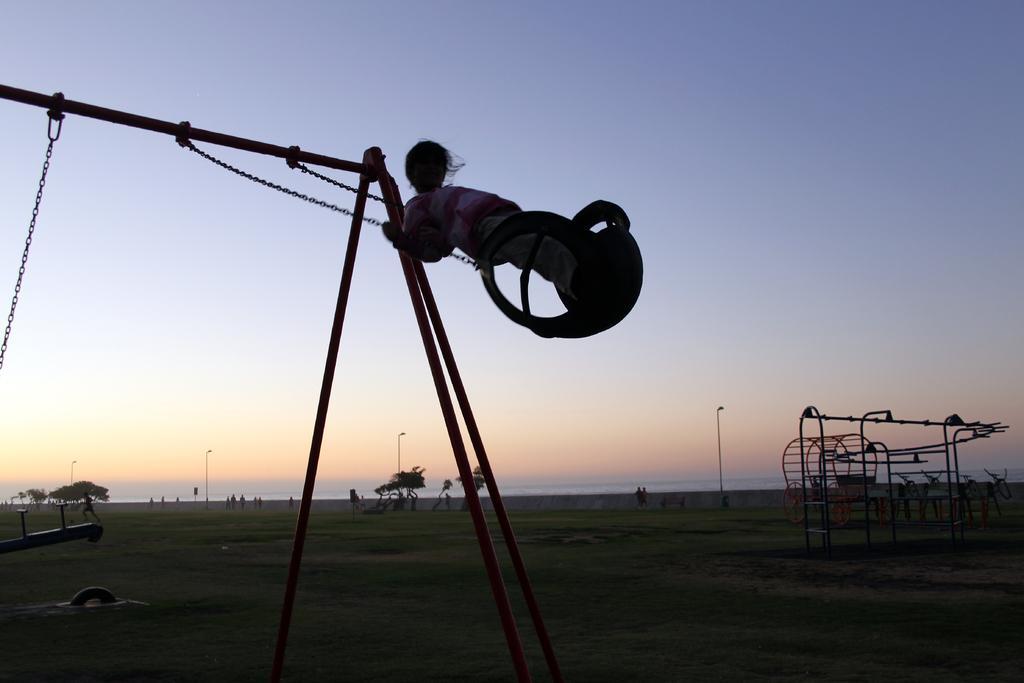Please provide a concise description of this image. In this image in the front there is a person swinging. In the background there is grass on the ground, there are iron rods and there is a cart, there are persons, trees and poles and there is water. 